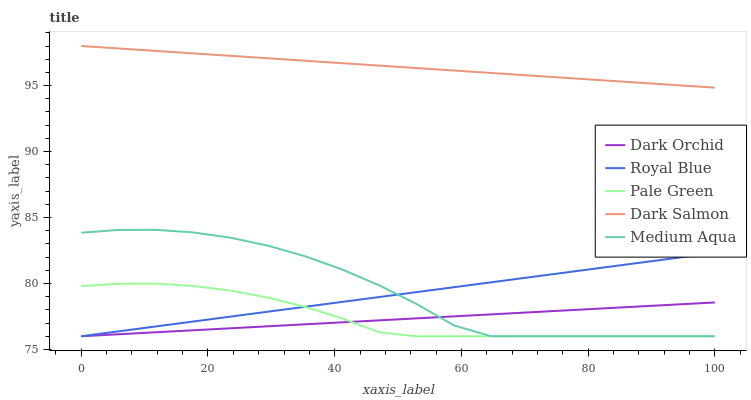Does Dark Orchid have the minimum area under the curve?
Answer yes or no. Yes. Does Dark Salmon have the maximum area under the curve?
Answer yes or no. Yes. Does Pale Green have the minimum area under the curve?
Answer yes or no. No. Does Pale Green have the maximum area under the curve?
Answer yes or no. No. Is Royal Blue the smoothest?
Answer yes or no. Yes. Is Medium Aqua the roughest?
Answer yes or no. Yes. Is Pale Green the smoothest?
Answer yes or no. No. Is Pale Green the roughest?
Answer yes or no. No. Does Royal Blue have the lowest value?
Answer yes or no. Yes. Does Dark Salmon have the lowest value?
Answer yes or no. No. Does Dark Salmon have the highest value?
Answer yes or no. Yes. Does Pale Green have the highest value?
Answer yes or no. No. Is Pale Green less than Dark Salmon?
Answer yes or no. Yes. Is Dark Salmon greater than Dark Orchid?
Answer yes or no. Yes. Does Medium Aqua intersect Royal Blue?
Answer yes or no. Yes. Is Medium Aqua less than Royal Blue?
Answer yes or no. No. Is Medium Aqua greater than Royal Blue?
Answer yes or no. No. Does Pale Green intersect Dark Salmon?
Answer yes or no. No. 